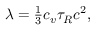Convert formula to latex. <formula><loc_0><loc_0><loc_500><loc_500>\begin{array} { r } { \lambda = \frac { 1 } { 3 } c _ { v } \tau _ { R } c ^ { 2 } , } \end{array}</formula> 